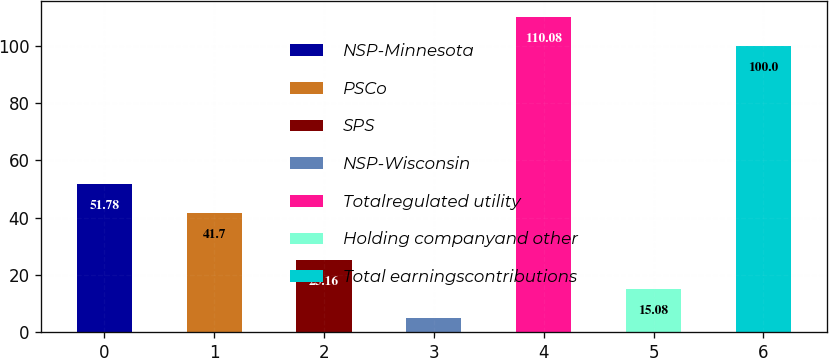<chart> <loc_0><loc_0><loc_500><loc_500><bar_chart><fcel>NSP-Minnesota<fcel>PSCo<fcel>SPS<fcel>NSP-Wisconsin<fcel>Totalregulated utility<fcel>Holding companyand other<fcel>Total earningscontributions<nl><fcel>51.78<fcel>41.7<fcel>25.16<fcel>5<fcel>110.08<fcel>15.08<fcel>100<nl></chart> 